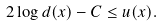Convert formula to latex. <formula><loc_0><loc_0><loc_500><loc_500>2 \log d ( x ) - C \leq u ( x ) .</formula> 